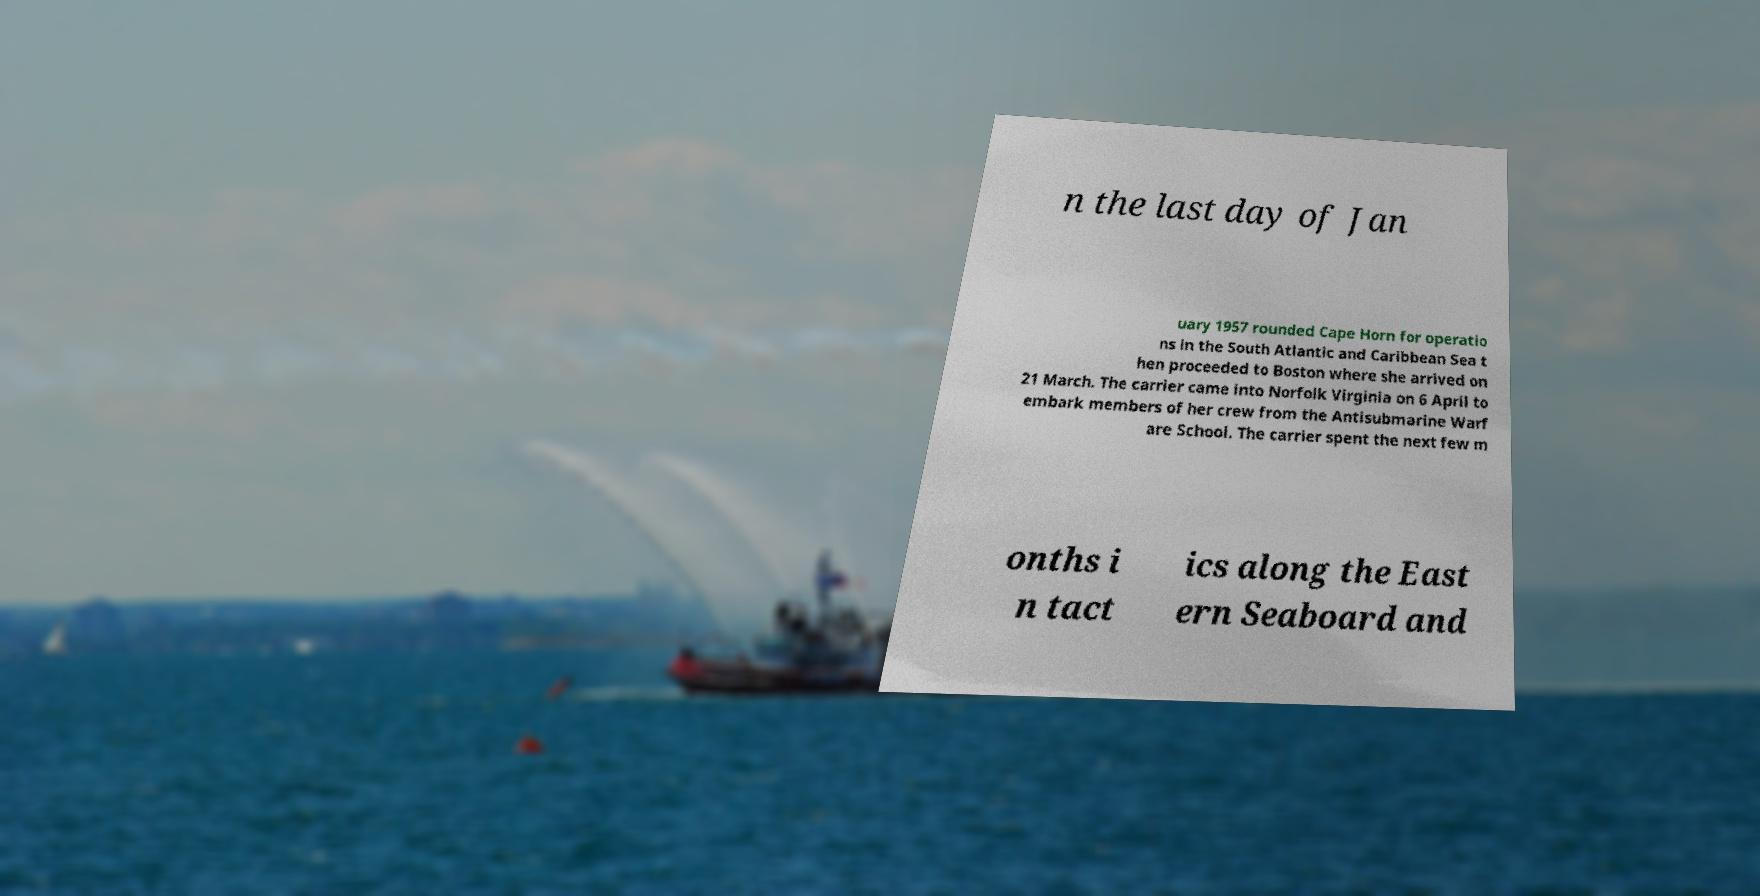There's text embedded in this image that I need extracted. Can you transcribe it verbatim? n the last day of Jan uary 1957 rounded Cape Horn for operatio ns in the South Atlantic and Caribbean Sea t hen proceeded to Boston where she arrived on 21 March. The carrier came into Norfolk Virginia on 6 April to embark members of her crew from the Antisubmarine Warf are School. The carrier spent the next few m onths i n tact ics along the East ern Seaboard and 